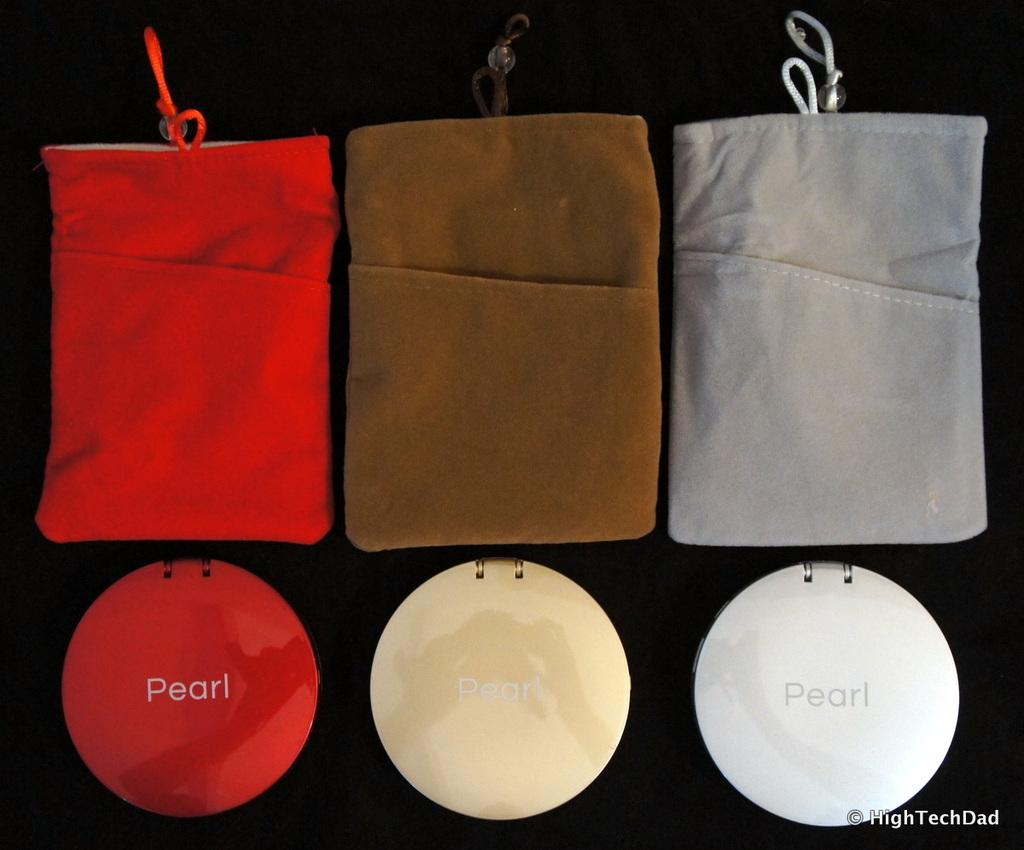What type of objects are present in the image? There are pouches and boxes in the image. How many different colors do the pouches come in? The pouches come in three different colors. What colors are the boxes in the image? The boxes come in three different colors: red, brown, and grey. Can you see any waves in the image? There are no waves present in the image. Is there a man interacting with the pouches or boxes in the image? There is no man present in the image. 